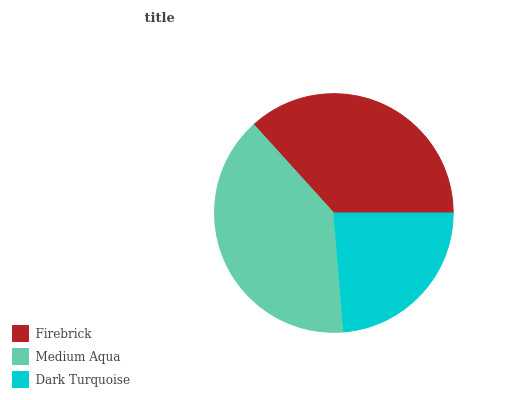Is Dark Turquoise the minimum?
Answer yes or no. Yes. Is Medium Aqua the maximum?
Answer yes or no. Yes. Is Medium Aqua the minimum?
Answer yes or no. No. Is Dark Turquoise the maximum?
Answer yes or no. No. Is Medium Aqua greater than Dark Turquoise?
Answer yes or no. Yes. Is Dark Turquoise less than Medium Aqua?
Answer yes or no. Yes. Is Dark Turquoise greater than Medium Aqua?
Answer yes or no. No. Is Medium Aqua less than Dark Turquoise?
Answer yes or no. No. Is Firebrick the high median?
Answer yes or no. Yes. Is Firebrick the low median?
Answer yes or no. Yes. Is Medium Aqua the high median?
Answer yes or no. No. Is Dark Turquoise the low median?
Answer yes or no. No. 